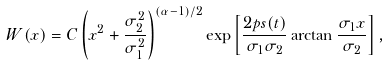Convert formula to latex. <formula><loc_0><loc_0><loc_500><loc_500>W ( x ) = C \left ( x ^ { 2 } + \frac { \sigma _ { 2 } ^ { 2 } } { \sigma _ { 1 } ^ { 2 } } \right ) ^ { ( \alpha - 1 ) / 2 } \exp \left [ \frac { 2 p s ( t ) } { \sigma _ { 1 } \sigma _ { 2 } } \arctan \frac { \sigma _ { 1 } x } { \sigma _ { 2 } } \right ] ,</formula> 